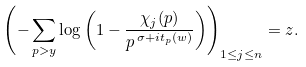Convert formula to latex. <formula><loc_0><loc_0><loc_500><loc_500>\left ( - \sum _ { p > y } \log \left ( 1 - \frac { \chi _ { j } ( p ) } { p ^ { \, \sigma + i t _ { p } ( w ) } } \right ) \right ) _ { 1 \leq j \leq n } = z .</formula> 